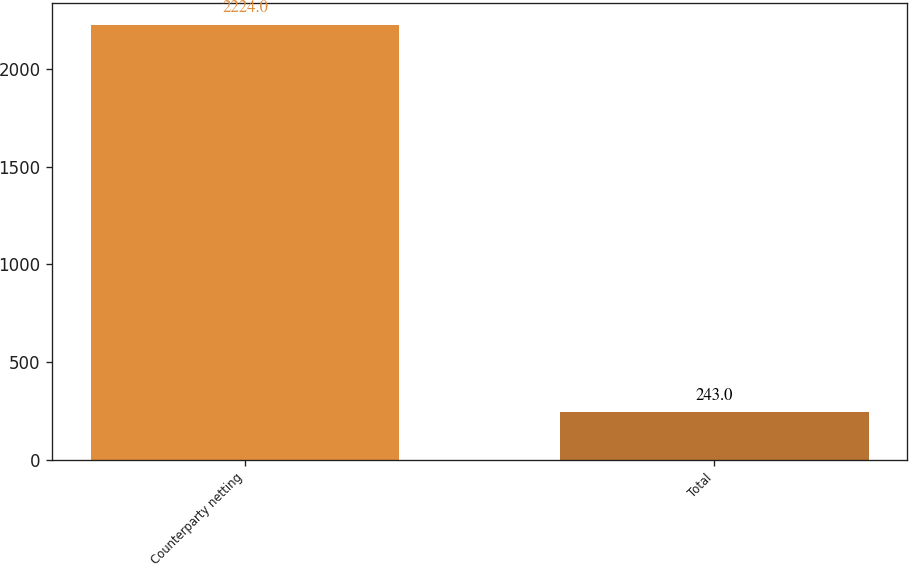Convert chart to OTSL. <chart><loc_0><loc_0><loc_500><loc_500><bar_chart><fcel>Counterparty netting<fcel>Total<nl><fcel>2224<fcel>243<nl></chart> 